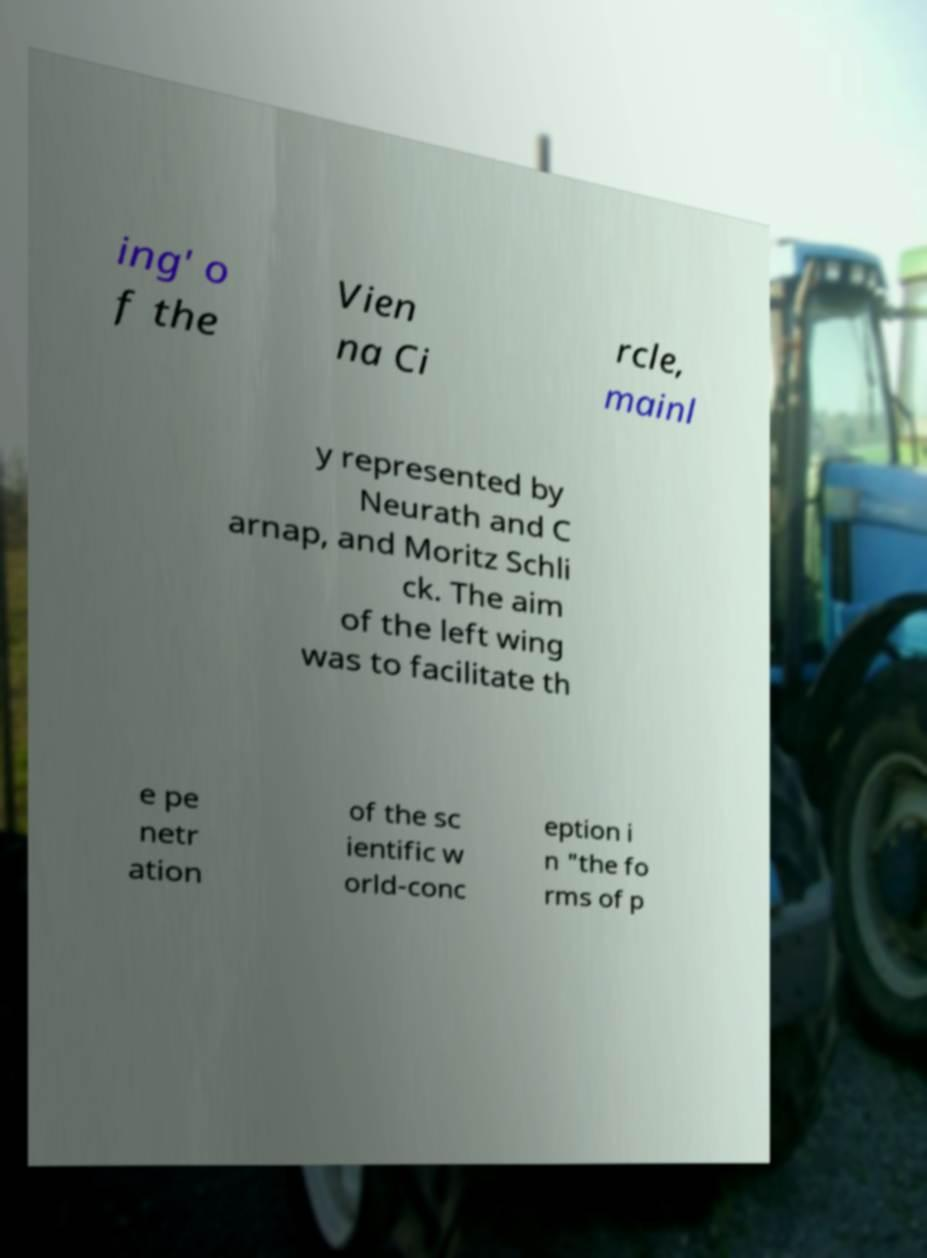For documentation purposes, I need the text within this image transcribed. Could you provide that? ing' o f the Vien na Ci rcle, mainl y represented by Neurath and C arnap, and Moritz Schli ck. The aim of the left wing was to facilitate th e pe netr ation of the sc ientific w orld-conc eption i n "the fo rms of p 